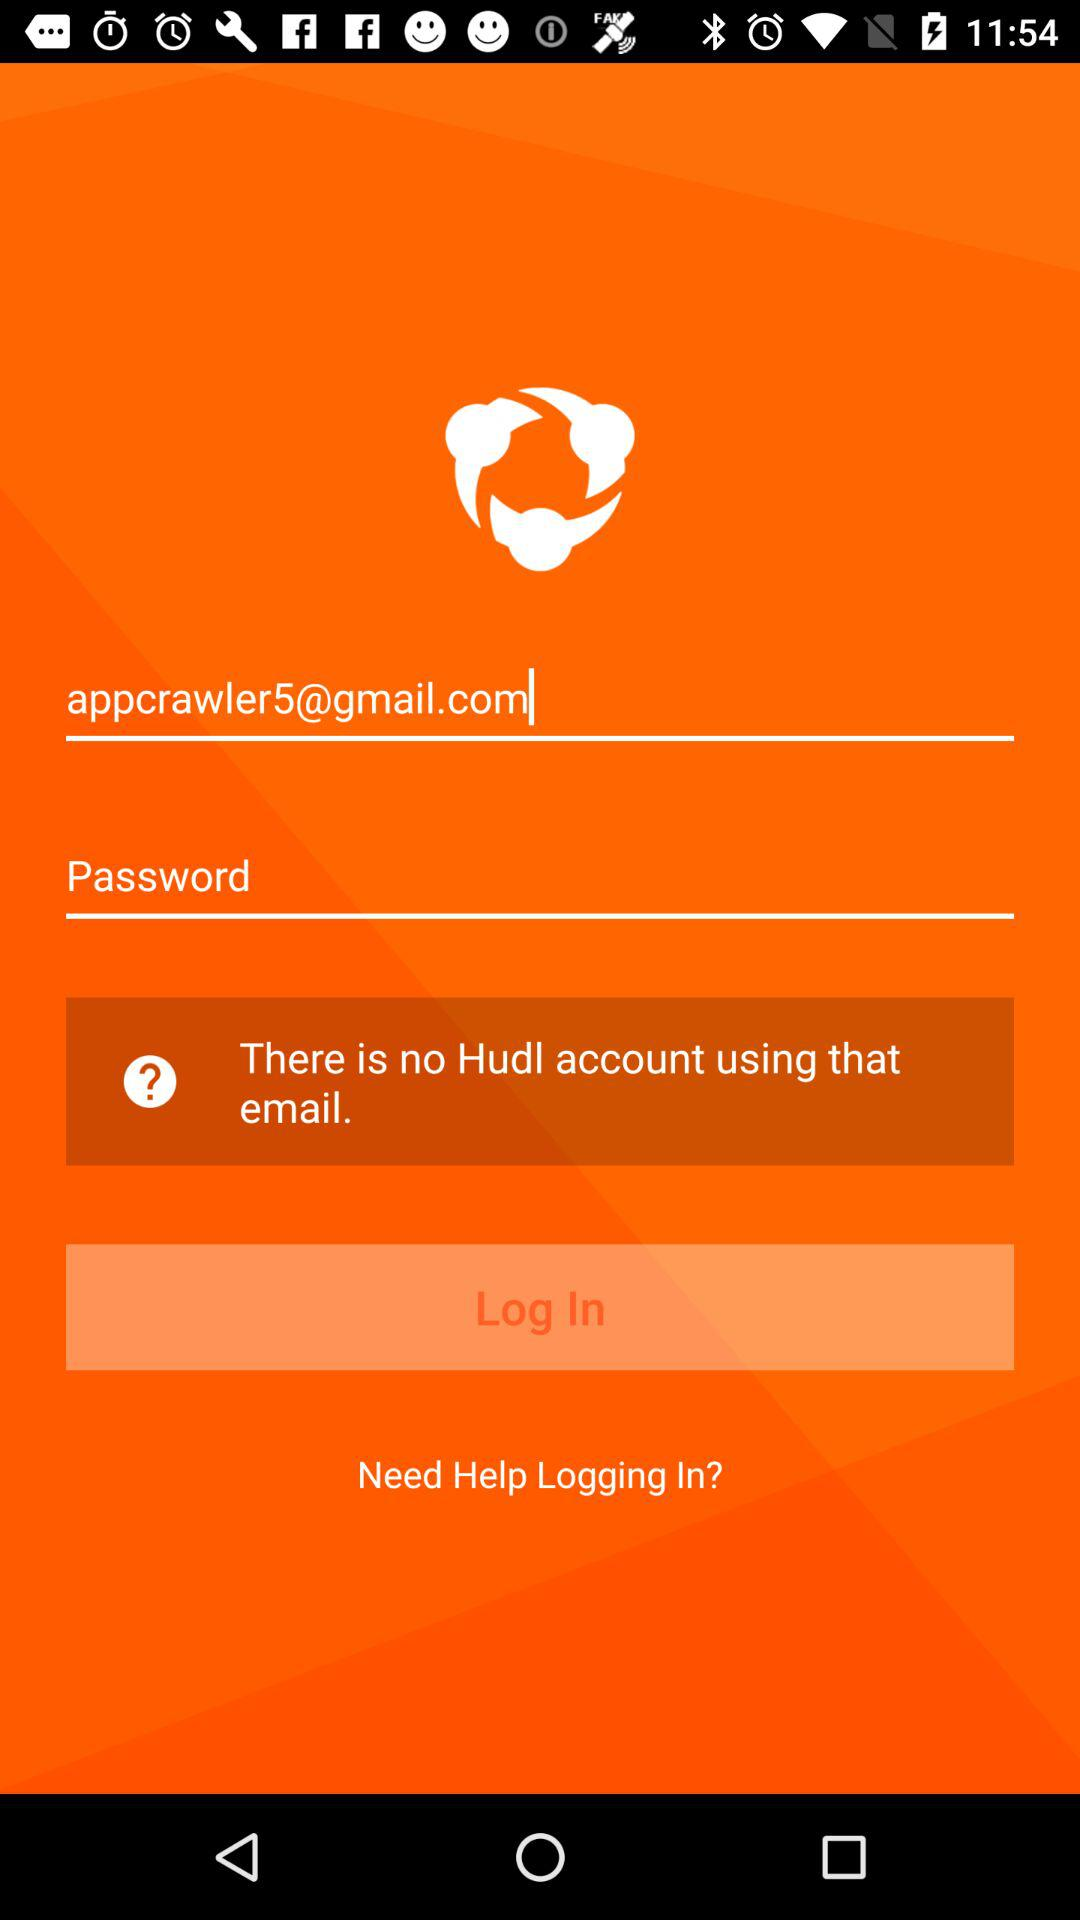What is the name of the application? The name of the application is "Hudl". 